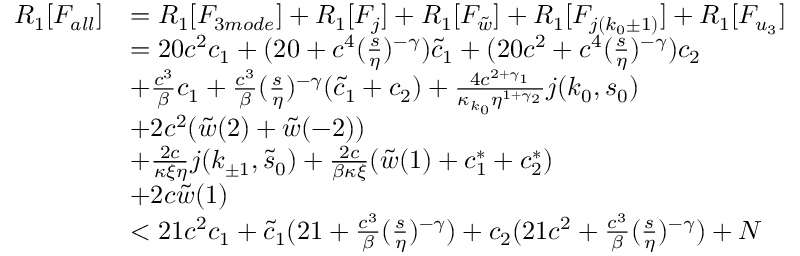Convert formula to latex. <formula><loc_0><loc_0><loc_500><loc_500>\begin{array} { r l } { R _ { 1 } [ F _ { a l l } ] } & { = R _ { 1 } [ F _ { 3 m o d e } ] + R _ { 1 } [ F _ { j } ] + R _ { 1 } [ F _ { \tilde { w } } ] + R _ { 1 } [ F _ { j ( k _ { 0 } \pm 1 ) } ] + R _ { 1 } [ F _ { u _ { 3 } } ] } \\ & { = 2 0 c ^ { 2 } c _ { 1 } + ( 2 0 + c ^ { 4 } ( \frac { s } { \eta } ) ^ { - \gamma } ) \tilde { c } _ { 1 } + ( 2 0 c ^ { 2 } + c ^ { 4 } ( \frac { s } { \eta } ) ^ { - \gamma } ) c _ { 2 } } \\ & { + \frac { c ^ { 3 } } \beta c _ { 1 } + \frac { c ^ { 3 } } \beta ( \frac { s } { \eta } ) ^ { - \gamma } ( \tilde { c } _ { 1 } + c _ { 2 } ) + \frac { 4 c ^ { 2 + \gamma _ { 1 } } } { \kappa _ { k _ { 0 } } \eta ^ { 1 + \gamma _ { 2 } } } j ( k _ { 0 } , s _ { 0 } ) } \\ & { + 2 c ^ { 2 } ( \tilde { w } ( 2 ) + \tilde { w } ( - 2 ) ) } \\ & { + \frac { 2 c } { \kappa \xi \eta } j ( k _ { \pm 1 } , \tilde { s } _ { 0 } ) + \frac { 2 c } { \beta \kappa \xi } ( \tilde { w } ( 1 ) + c _ { 1 } ^ { \ast } + c _ { 2 } ^ { \ast } ) } \\ & { + 2 c \tilde { w } ( 1 ) } \\ & { < 2 1 c ^ { 2 } c _ { 1 } + \tilde { c } _ { 1 } ( 2 1 + \frac { c ^ { 3 } } \beta ( \frac { s } { \eta } ) ^ { - \gamma } ) + c _ { 2 } ( 2 1 c ^ { 2 } + \frac { c ^ { 3 } } \beta ( \frac { s } { \eta } ) ^ { - \gamma } ) + N } \end{array}</formula> 